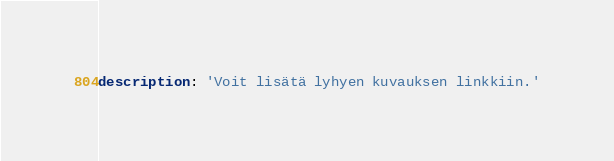<code> <loc_0><loc_0><loc_500><loc_500><_YAML_>description: 'Voit lisätä lyhyen kuvauksen linkkiin.'
</code> 